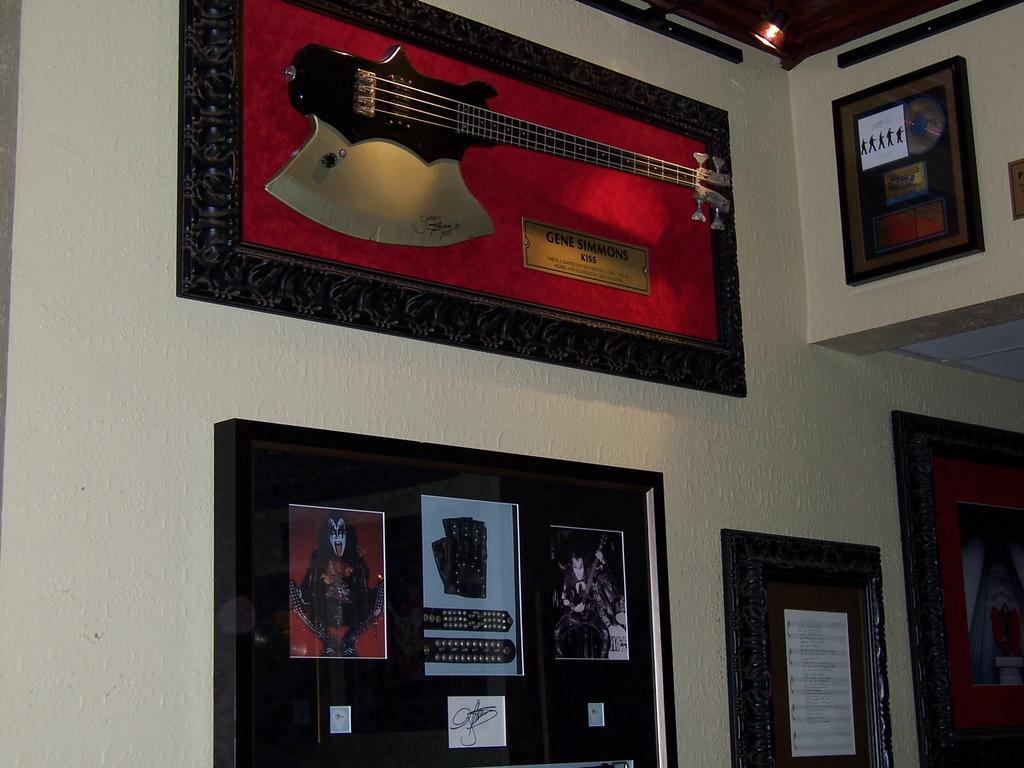What is present on the wall in the image? There are photo frames and a noticeboard on the wall in the image. What can be seen hanging on the noticeboard? There is a paper pasted on the wall or noticeboard. What musical instrument is visible in the image? A guitar is visible in the image. What might be used for displaying notices or announcements in the image? The noticeboard can be used for displaying notices or announcements. What type of zinc is present in the image? There is no zinc present in the image. How many fowl can be seen in the image? There are no fowl visible in the image. 